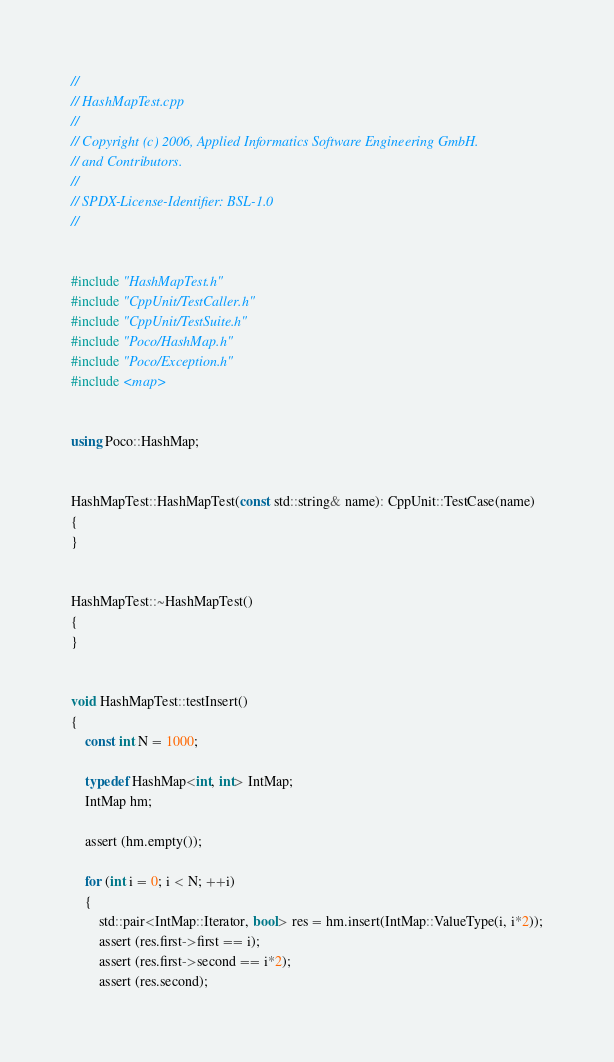<code> <loc_0><loc_0><loc_500><loc_500><_C++_>//
// HashMapTest.cpp
//
// Copyright (c) 2006, Applied Informatics Software Engineering GmbH.
// and Contributors.
//
// SPDX-License-Identifier:	BSL-1.0
//


#include "HashMapTest.h"
#include "CppUnit/TestCaller.h"
#include "CppUnit/TestSuite.h"
#include "Poco/HashMap.h"
#include "Poco/Exception.h"
#include <map>


using Poco::HashMap;


HashMapTest::HashMapTest(const std::string& name): CppUnit::TestCase(name)
{
}


HashMapTest::~HashMapTest()
{
}


void HashMapTest::testInsert()
{
	const int N = 1000;

	typedef HashMap<int, int> IntMap;
	IntMap hm;
	
	assert (hm.empty());
	
	for (int i = 0; i < N; ++i)
	{
		std::pair<IntMap::Iterator, bool> res = hm.insert(IntMap::ValueType(i, i*2));
		assert (res.first->first == i);
		assert (res.first->second == i*2);
		assert (res.second);</code> 